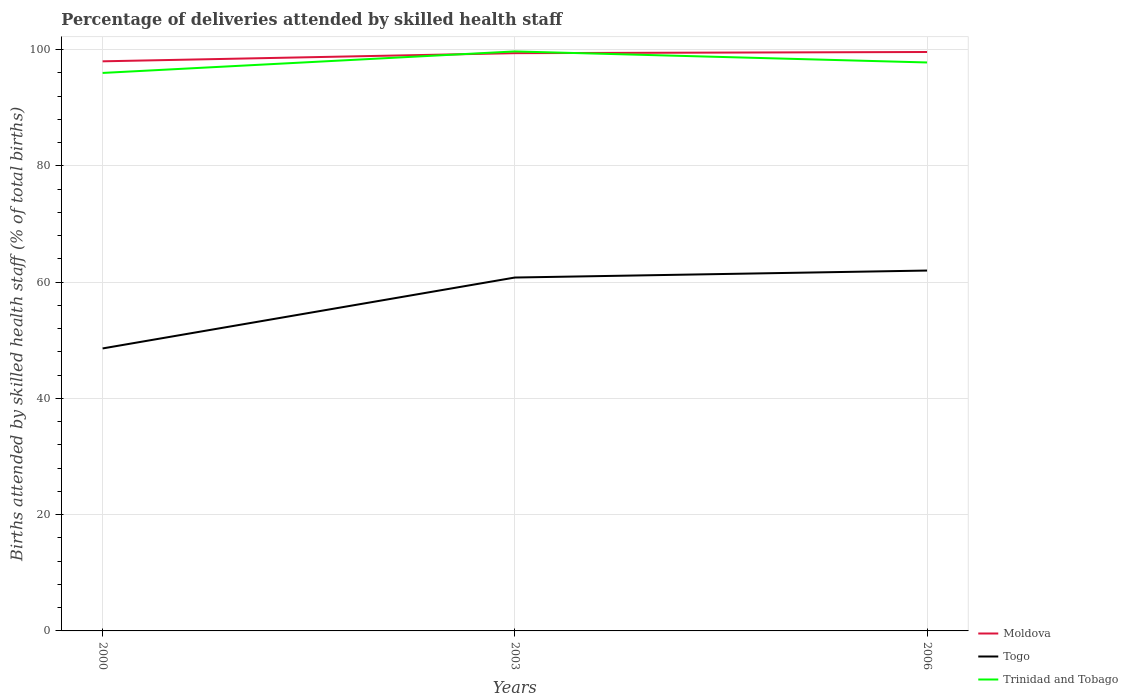Is the number of lines equal to the number of legend labels?
Make the answer very short. Yes. What is the total percentage of births attended by skilled health staff in Moldova in the graph?
Your answer should be very brief. -1.6. What is the difference between the highest and the second highest percentage of births attended by skilled health staff in Togo?
Your answer should be very brief. 13.4. What is the difference between the highest and the lowest percentage of births attended by skilled health staff in Togo?
Offer a very short reply. 2. Is the percentage of births attended by skilled health staff in Moldova strictly greater than the percentage of births attended by skilled health staff in Togo over the years?
Provide a short and direct response. No. How many years are there in the graph?
Provide a succinct answer. 3. What is the difference between two consecutive major ticks on the Y-axis?
Your response must be concise. 20. Are the values on the major ticks of Y-axis written in scientific E-notation?
Ensure brevity in your answer.  No. How many legend labels are there?
Provide a short and direct response. 3. How are the legend labels stacked?
Make the answer very short. Vertical. What is the title of the graph?
Provide a short and direct response. Percentage of deliveries attended by skilled health staff. What is the label or title of the Y-axis?
Your answer should be very brief. Births attended by skilled health staff (% of total births). What is the Births attended by skilled health staff (% of total births) of Togo in 2000?
Your response must be concise. 48.6. What is the Births attended by skilled health staff (% of total births) of Trinidad and Tobago in 2000?
Your answer should be compact. 96. What is the Births attended by skilled health staff (% of total births) in Moldova in 2003?
Ensure brevity in your answer.  99.4. What is the Births attended by skilled health staff (% of total births) in Togo in 2003?
Offer a very short reply. 60.8. What is the Births attended by skilled health staff (% of total births) of Trinidad and Tobago in 2003?
Offer a terse response. 99.7. What is the Births attended by skilled health staff (% of total births) of Moldova in 2006?
Your response must be concise. 99.6. What is the Births attended by skilled health staff (% of total births) in Trinidad and Tobago in 2006?
Your answer should be compact. 97.8. Across all years, what is the maximum Births attended by skilled health staff (% of total births) in Moldova?
Offer a terse response. 99.6. Across all years, what is the maximum Births attended by skilled health staff (% of total births) in Togo?
Your response must be concise. 62. Across all years, what is the maximum Births attended by skilled health staff (% of total births) of Trinidad and Tobago?
Your answer should be very brief. 99.7. Across all years, what is the minimum Births attended by skilled health staff (% of total births) of Togo?
Provide a short and direct response. 48.6. Across all years, what is the minimum Births attended by skilled health staff (% of total births) in Trinidad and Tobago?
Ensure brevity in your answer.  96. What is the total Births attended by skilled health staff (% of total births) in Moldova in the graph?
Keep it short and to the point. 297. What is the total Births attended by skilled health staff (% of total births) in Togo in the graph?
Provide a short and direct response. 171.4. What is the total Births attended by skilled health staff (% of total births) in Trinidad and Tobago in the graph?
Offer a very short reply. 293.5. What is the difference between the Births attended by skilled health staff (% of total births) of Trinidad and Tobago in 2000 and that in 2006?
Provide a short and direct response. -1.8. What is the difference between the Births attended by skilled health staff (% of total births) of Moldova in 2000 and the Births attended by skilled health staff (% of total births) of Togo in 2003?
Keep it short and to the point. 37.2. What is the difference between the Births attended by skilled health staff (% of total births) in Moldova in 2000 and the Births attended by skilled health staff (% of total births) in Trinidad and Tobago in 2003?
Keep it short and to the point. -1.7. What is the difference between the Births attended by skilled health staff (% of total births) of Togo in 2000 and the Births attended by skilled health staff (% of total births) of Trinidad and Tobago in 2003?
Your answer should be very brief. -51.1. What is the difference between the Births attended by skilled health staff (% of total births) in Togo in 2000 and the Births attended by skilled health staff (% of total births) in Trinidad and Tobago in 2006?
Your answer should be very brief. -49.2. What is the difference between the Births attended by skilled health staff (% of total births) of Moldova in 2003 and the Births attended by skilled health staff (% of total births) of Togo in 2006?
Ensure brevity in your answer.  37.4. What is the difference between the Births attended by skilled health staff (% of total births) in Moldova in 2003 and the Births attended by skilled health staff (% of total births) in Trinidad and Tobago in 2006?
Make the answer very short. 1.6. What is the difference between the Births attended by skilled health staff (% of total births) of Togo in 2003 and the Births attended by skilled health staff (% of total births) of Trinidad and Tobago in 2006?
Your answer should be compact. -37. What is the average Births attended by skilled health staff (% of total births) in Togo per year?
Ensure brevity in your answer.  57.13. What is the average Births attended by skilled health staff (% of total births) of Trinidad and Tobago per year?
Your response must be concise. 97.83. In the year 2000, what is the difference between the Births attended by skilled health staff (% of total births) in Moldova and Births attended by skilled health staff (% of total births) in Togo?
Offer a very short reply. 49.4. In the year 2000, what is the difference between the Births attended by skilled health staff (% of total births) in Togo and Births attended by skilled health staff (% of total births) in Trinidad and Tobago?
Offer a terse response. -47.4. In the year 2003, what is the difference between the Births attended by skilled health staff (% of total births) in Moldova and Births attended by skilled health staff (% of total births) in Togo?
Keep it short and to the point. 38.6. In the year 2003, what is the difference between the Births attended by skilled health staff (% of total births) in Togo and Births attended by skilled health staff (% of total births) in Trinidad and Tobago?
Provide a succinct answer. -38.9. In the year 2006, what is the difference between the Births attended by skilled health staff (% of total births) of Moldova and Births attended by skilled health staff (% of total births) of Togo?
Your response must be concise. 37.6. In the year 2006, what is the difference between the Births attended by skilled health staff (% of total births) in Moldova and Births attended by skilled health staff (% of total births) in Trinidad and Tobago?
Give a very brief answer. 1.8. In the year 2006, what is the difference between the Births attended by skilled health staff (% of total births) of Togo and Births attended by skilled health staff (% of total births) of Trinidad and Tobago?
Make the answer very short. -35.8. What is the ratio of the Births attended by skilled health staff (% of total births) of Moldova in 2000 to that in 2003?
Your answer should be very brief. 0.99. What is the ratio of the Births attended by skilled health staff (% of total births) in Togo in 2000 to that in 2003?
Provide a succinct answer. 0.8. What is the ratio of the Births attended by skilled health staff (% of total births) in Trinidad and Tobago in 2000 to that in 2003?
Offer a terse response. 0.96. What is the ratio of the Births attended by skilled health staff (% of total births) in Moldova in 2000 to that in 2006?
Provide a short and direct response. 0.98. What is the ratio of the Births attended by skilled health staff (% of total births) of Togo in 2000 to that in 2006?
Offer a very short reply. 0.78. What is the ratio of the Births attended by skilled health staff (% of total births) in Trinidad and Tobago in 2000 to that in 2006?
Give a very brief answer. 0.98. What is the ratio of the Births attended by skilled health staff (% of total births) in Togo in 2003 to that in 2006?
Provide a succinct answer. 0.98. What is the ratio of the Births attended by skilled health staff (% of total births) of Trinidad and Tobago in 2003 to that in 2006?
Offer a very short reply. 1.02. What is the difference between the highest and the lowest Births attended by skilled health staff (% of total births) of Moldova?
Make the answer very short. 1.6. What is the difference between the highest and the lowest Births attended by skilled health staff (% of total births) of Trinidad and Tobago?
Your answer should be compact. 3.7. 